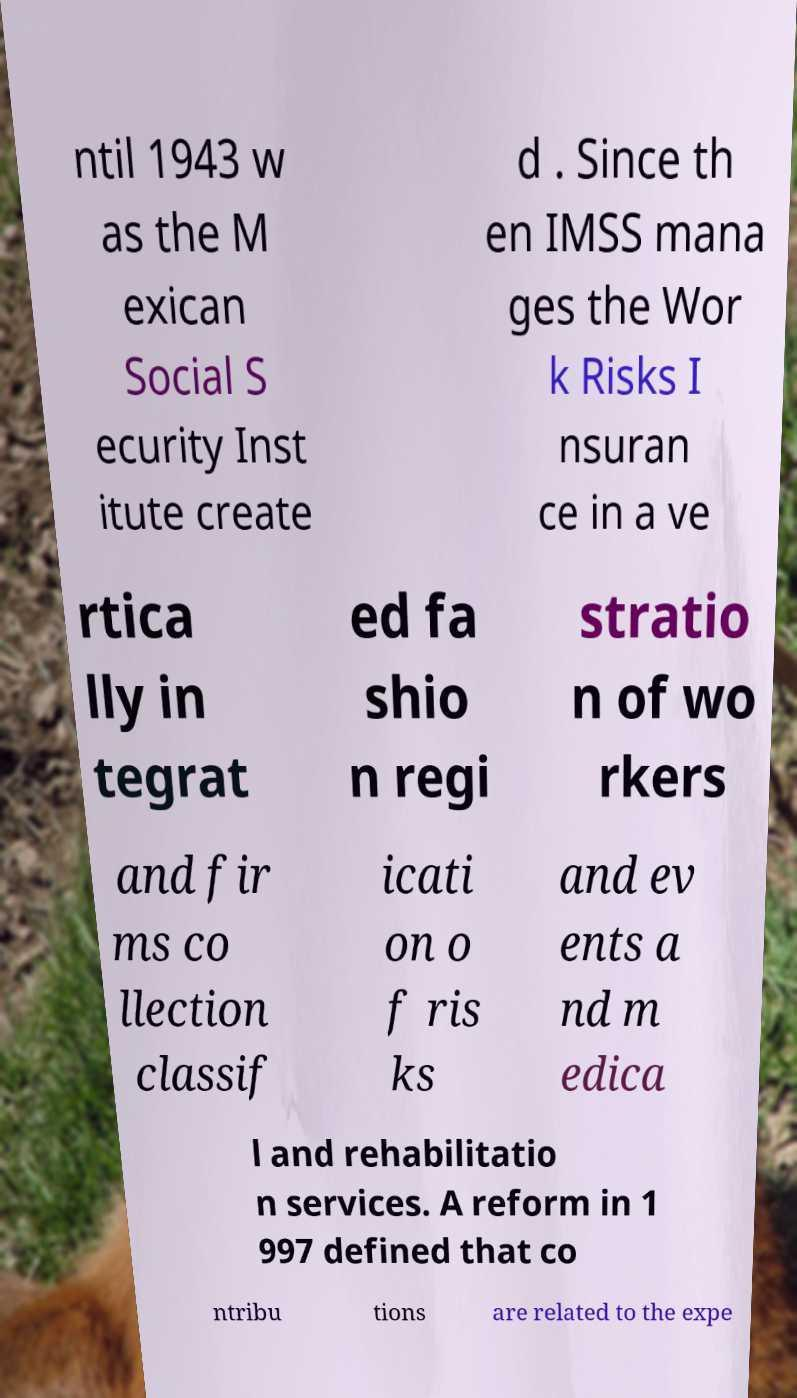Can you accurately transcribe the text from the provided image for me? ntil 1943 w as the M exican Social S ecurity Inst itute create d . Since th en IMSS mana ges the Wor k Risks I nsuran ce in a ve rtica lly in tegrat ed fa shio n regi stratio n of wo rkers and fir ms co llection classif icati on o f ris ks and ev ents a nd m edica l and rehabilitatio n services. A reform in 1 997 defined that co ntribu tions are related to the expe 